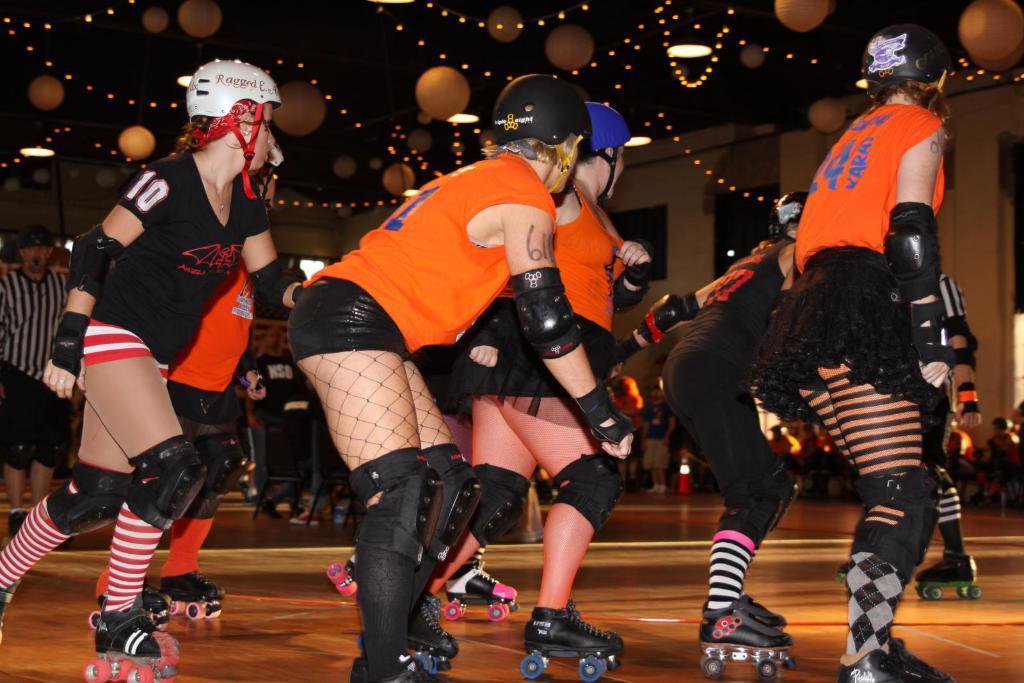Can you describe this image briefly? In this image we can see a few girls are skating on the floor. At the top of the image there are few balloons and lights. 